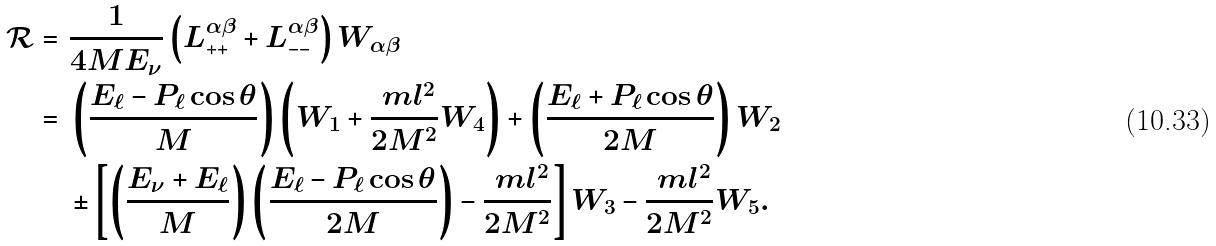Convert formula to latex. <formula><loc_0><loc_0><loc_500><loc_500>\mathcal { R } = & \ \frac { 1 } { 4 M E _ { \nu } } \left ( L _ { + + } ^ { \alpha \beta } + L _ { - - } ^ { \alpha \beta } \right ) W _ { \alpha \beta } \\ = & \ \left ( \frac { E _ { \ell } - P _ { \ell } \cos \theta } { M } \right ) \left ( W _ { 1 } + \frac { \ m l ^ { 2 } } { 2 M ^ { 2 } } W _ { 4 } \right ) + \left ( \frac { E _ { \ell } + P _ { \ell } \cos \theta } { 2 M } \right ) W _ { 2 } \\ & \ \pm \left [ \left ( \frac { E _ { \nu } + E _ { \ell } } { M } \right ) \left ( \frac { E _ { \ell } - P _ { \ell } \cos \theta } { 2 M } \right ) - \frac { \ m l ^ { 2 } } { 2 M ^ { 2 } } \right ] W _ { 3 } - \frac { \ m l ^ { 2 } } { 2 M ^ { 2 } } W _ { 5 } .</formula> 